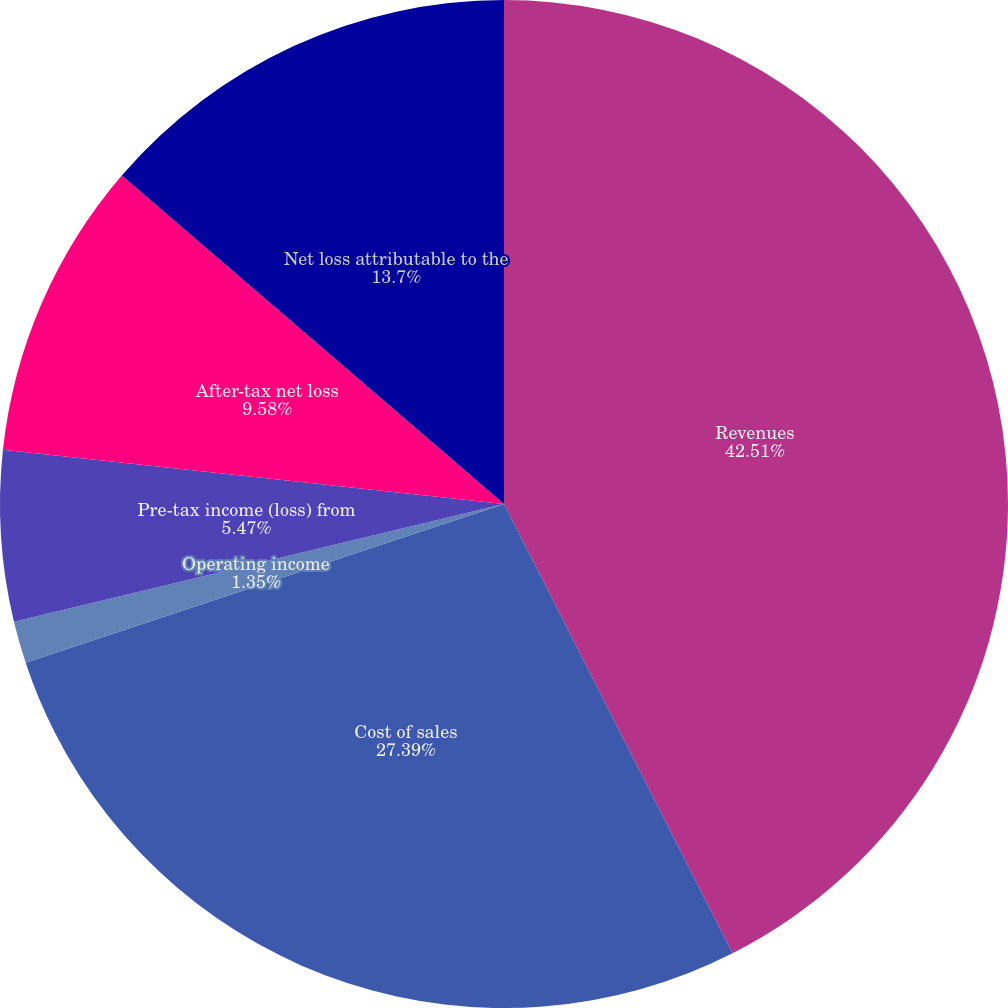Convert chart. <chart><loc_0><loc_0><loc_500><loc_500><pie_chart><fcel>Revenues<fcel>Cost of sales<fcel>Operating income<fcel>Pre-tax income (loss) from<fcel>After-tax net loss<fcel>Net loss attributable to the<nl><fcel>42.51%<fcel>27.39%<fcel>1.35%<fcel>5.47%<fcel>9.58%<fcel>13.7%<nl></chart> 